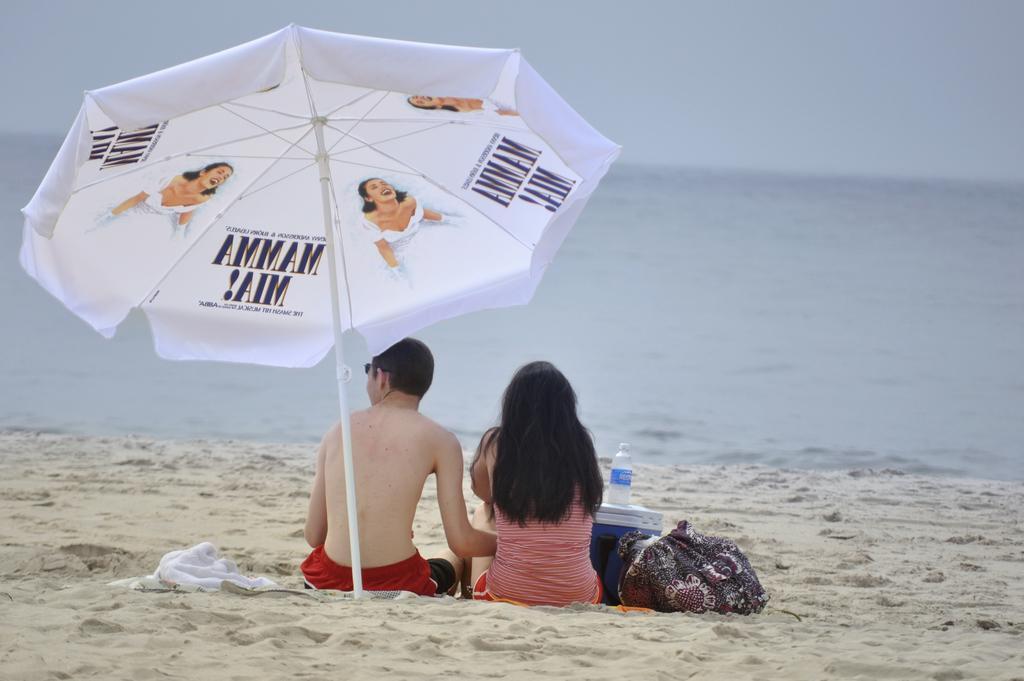In one or two sentences, can you explain what this image depicts? In this image I can see two persons sitting. The person at right wearing red and white color shirt and the person at left wearing red color short. I can also see an umbrella which is in white color, background I can see water and sky in gray color. 